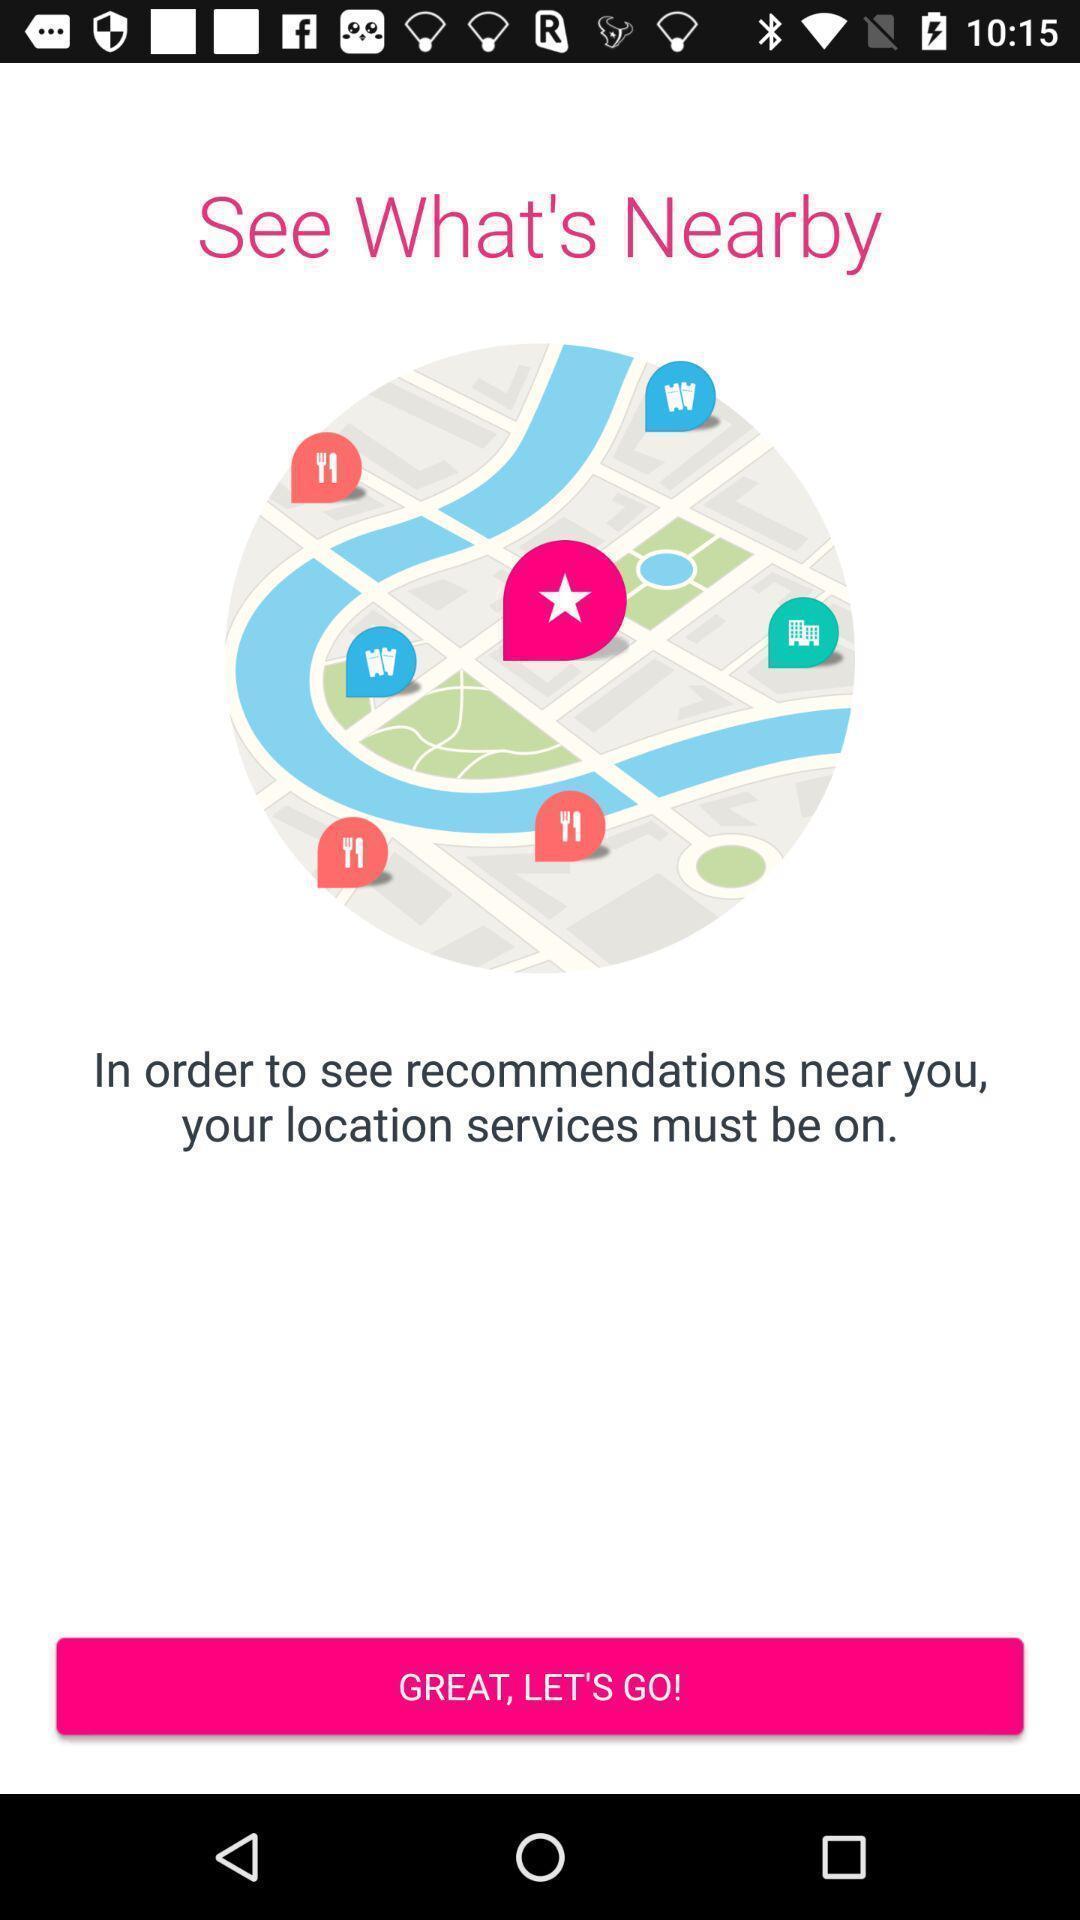Describe the key features of this screenshot. Welcome page to enable location services. 